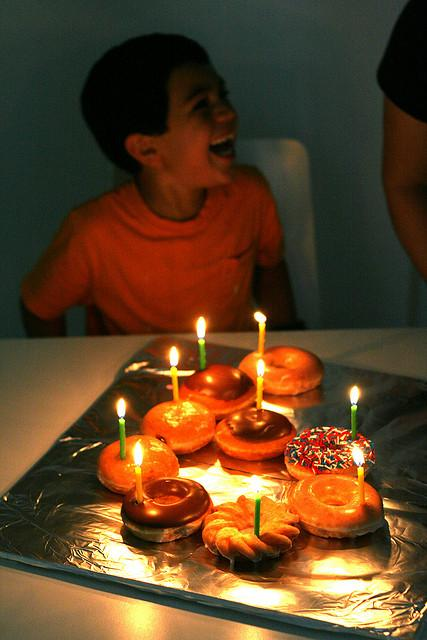What color is the only icing element used for the birthday donuts?

Choices:
A) brown
B) white
C) pink
D) light brown brown 